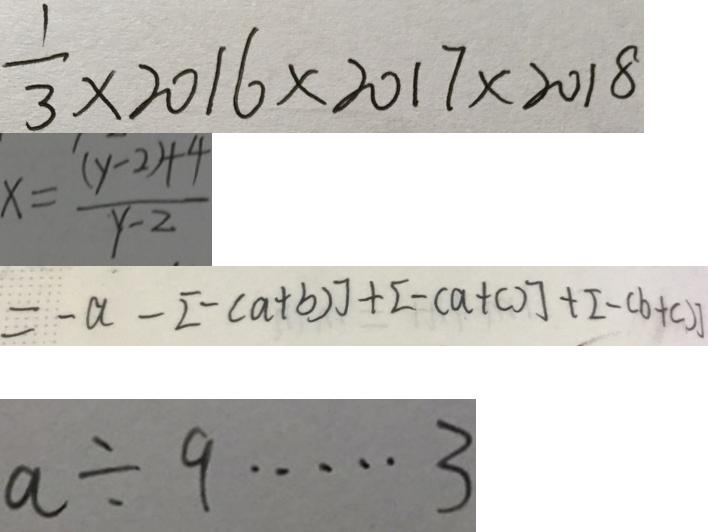<formula> <loc_0><loc_0><loc_500><loc_500>\frac { 1 } { 3 } \times 2 0 1 6 \times 2 0 1 7 \times 2 0 1 8 
 x = \frac { ( y - 2 ) + 4 } { y - 2 } 
 = - a - [ - ( a + b ) ] + [ - ( a + c ) ] + [ - ( b + c ) ] 
 a \div 9 \cdots 3</formula> 